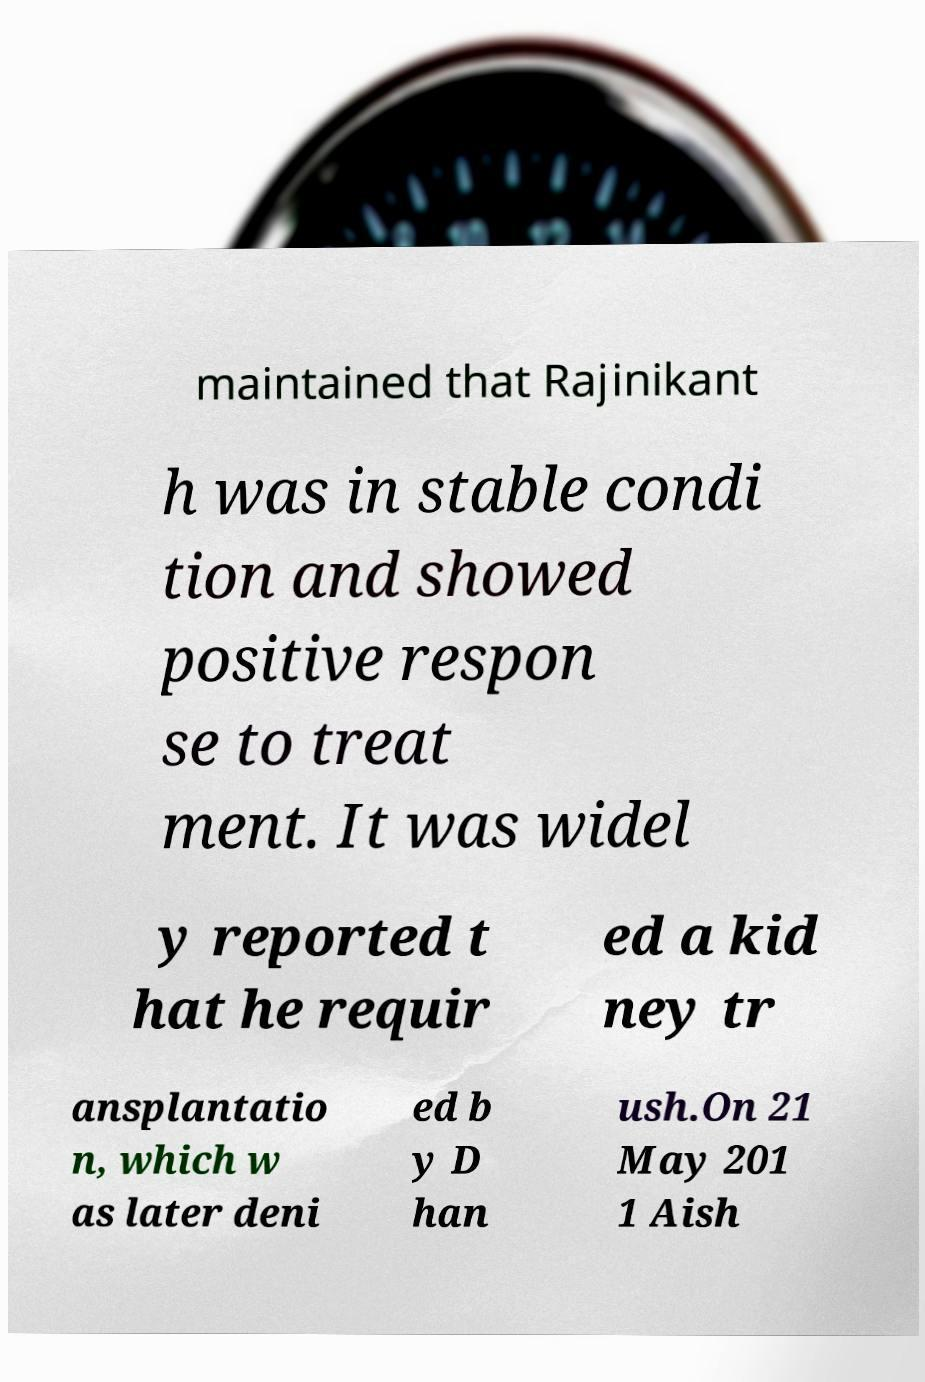Can you accurately transcribe the text from the provided image for me? maintained that Rajinikant h was in stable condi tion and showed positive respon se to treat ment. It was widel y reported t hat he requir ed a kid ney tr ansplantatio n, which w as later deni ed b y D han ush.On 21 May 201 1 Aish 